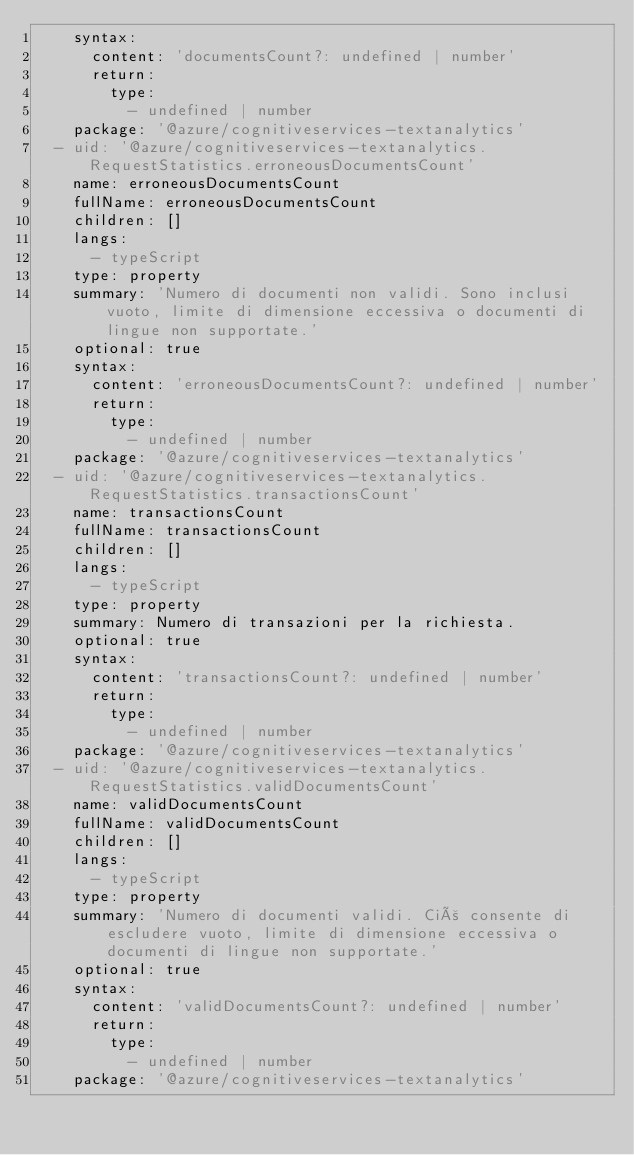Convert code to text. <code><loc_0><loc_0><loc_500><loc_500><_YAML_>    syntax:
      content: 'documentsCount?: undefined | number'
      return:
        type:
          - undefined | number
    package: '@azure/cognitiveservices-textanalytics'
  - uid: '@azure/cognitiveservices-textanalytics.RequestStatistics.erroneousDocumentsCount'
    name: erroneousDocumentsCount
    fullName: erroneousDocumentsCount
    children: []
    langs:
      - typeScript
    type: property
    summary: 'Numero di documenti non validi. Sono inclusi vuoto, limite di dimensione eccessiva o documenti di lingue non supportate.'
    optional: true
    syntax:
      content: 'erroneousDocumentsCount?: undefined | number'
      return:
        type:
          - undefined | number
    package: '@azure/cognitiveservices-textanalytics'
  - uid: '@azure/cognitiveservices-textanalytics.RequestStatistics.transactionsCount'
    name: transactionsCount
    fullName: transactionsCount
    children: []
    langs:
      - typeScript
    type: property
    summary: Numero di transazioni per la richiesta.
    optional: true
    syntax:
      content: 'transactionsCount?: undefined | number'
      return:
        type:
          - undefined | number
    package: '@azure/cognitiveservices-textanalytics'
  - uid: '@azure/cognitiveservices-textanalytics.RequestStatistics.validDocumentsCount'
    name: validDocumentsCount
    fullName: validDocumentsCount
    children: []
    langs:
      - typeScript
    type: property
    summary: 'Numero di documenti validi. Ciò consente di escludere vuoto, limite di dimensione eccessiva o documenti di lingue non supportate.'
    optional: true
    syntax:
      content: 'validDocumentsCount?: undefined | number'
      return:
        type:
          - undefined | number
    package: '@azure/cognitiveservices-textanalytics'</code> 